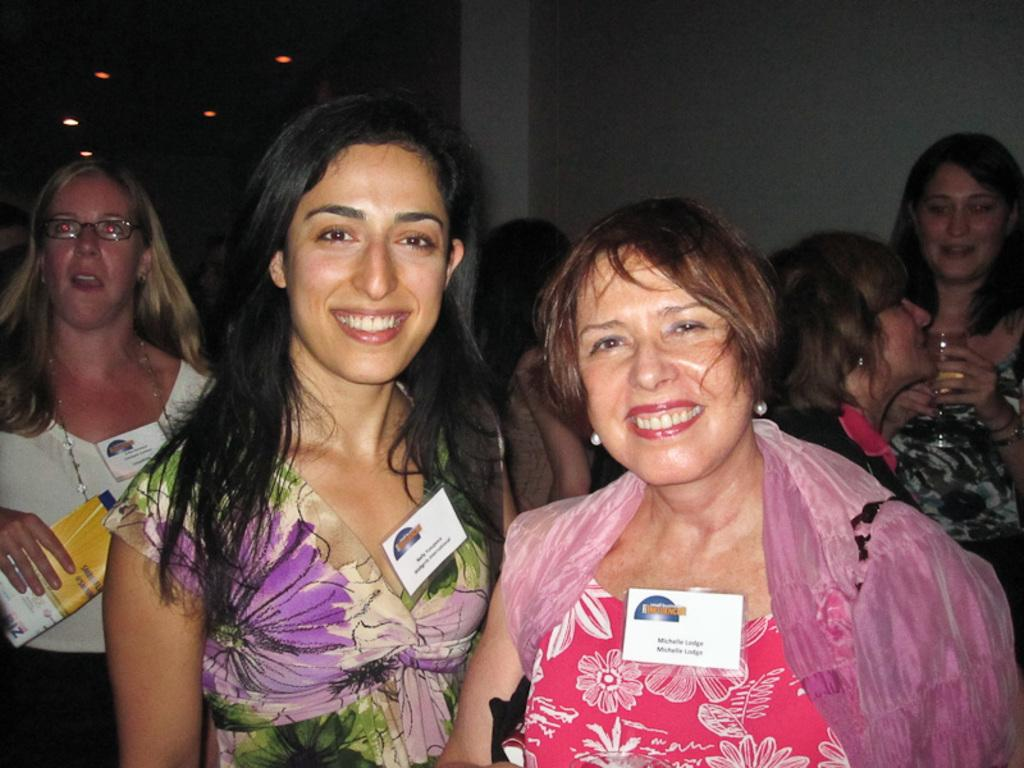What can be seen in the front of the image? There is a group of women standing in the front of the image. What is the background of the image? There is a wall in the image. How would you describe the lighting in the image? The image appears to be a little dark. What type of board is being used by the women in the image? There is no board present in the image; it only shows a group of women standing in front of a wall. 